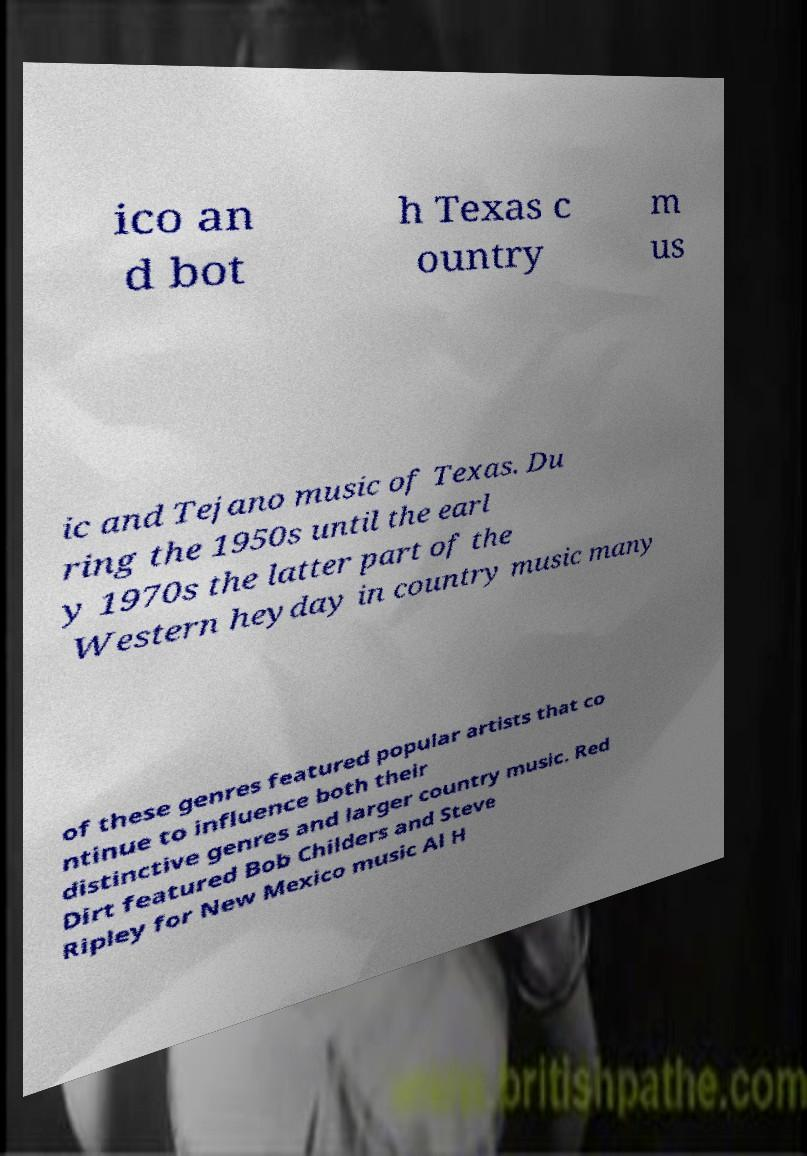Could you assist in decoding the text presented in this image and type it out clearly? ico an d bot h Texas c ountry m us ic and Tejano music of Texas. Du ring the 1950s until the earl y 1970s the latter part of the Western heyday in country music many of these genres featured popular artists that co ntinue to influence both their distinctive genres and larger country music. Red Dirt featured Bob Childers and Steve Ripley for New Mexico music Al H 